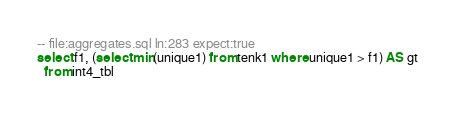<code> <loc_0><loc_0><loc_500><loc_500><_SQL_>-- file:aggregates.sql ln:283 expect:true
select f1, (select min(unique1) from tenk1 where unique1 > f1) AS gt
  from int4_tbl
</code> 